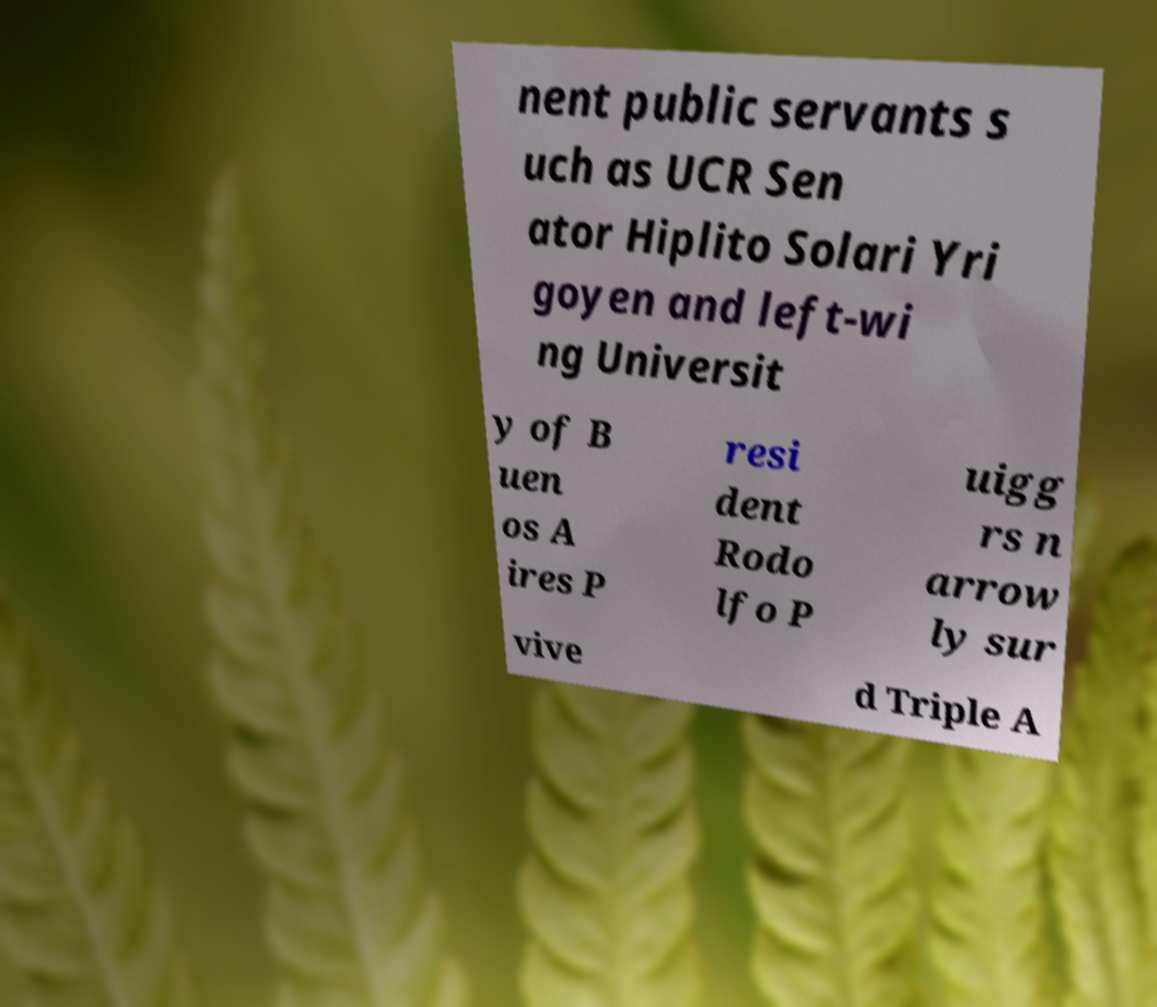Could you assist in decoding the text presented in this image and type it out clearly? nent public servants s uch as UCR Sen ator Hiplito Solari Yri goyen and left-wi ng Universit y of B uen os A ires P resi dent Rodo lfo P uigg rs n arrow ly sur vive d Triple A 